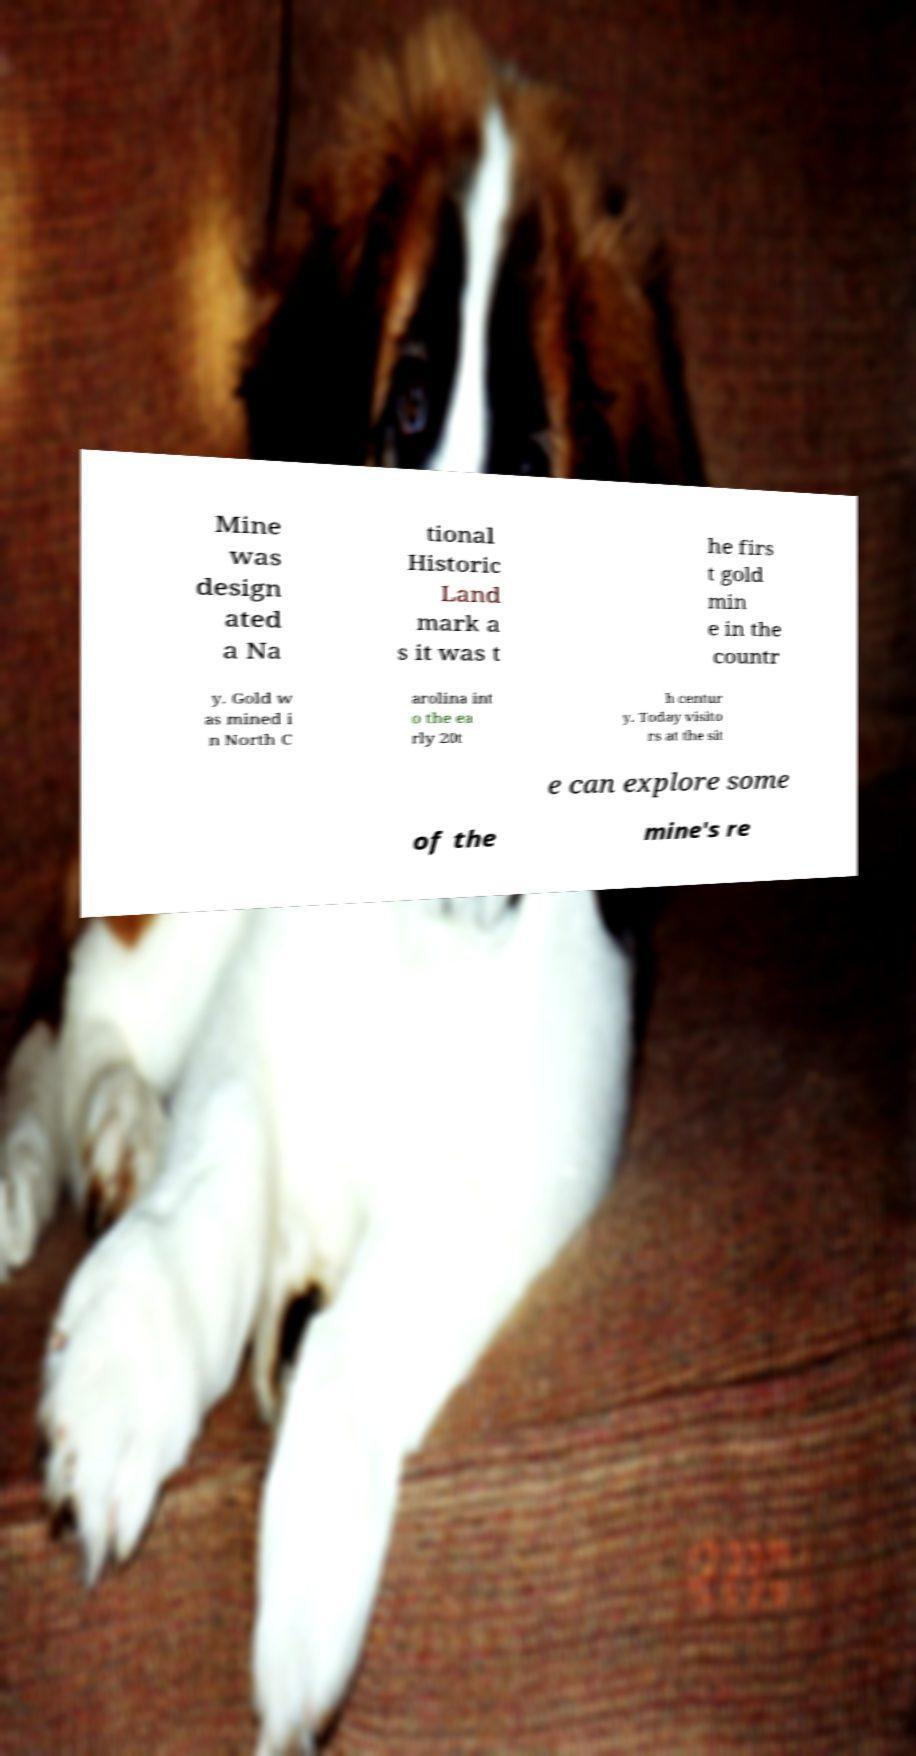Please identify and transcribe the text found in this image. Mine was design ated a Na tional Historic Land mark a s it was t he firs t gold min e in the countr y. Gold w as mined i n North C arolina int o the ea rly 20t h centur y. Today visito rs at the sit e can explore some of the mine's re 